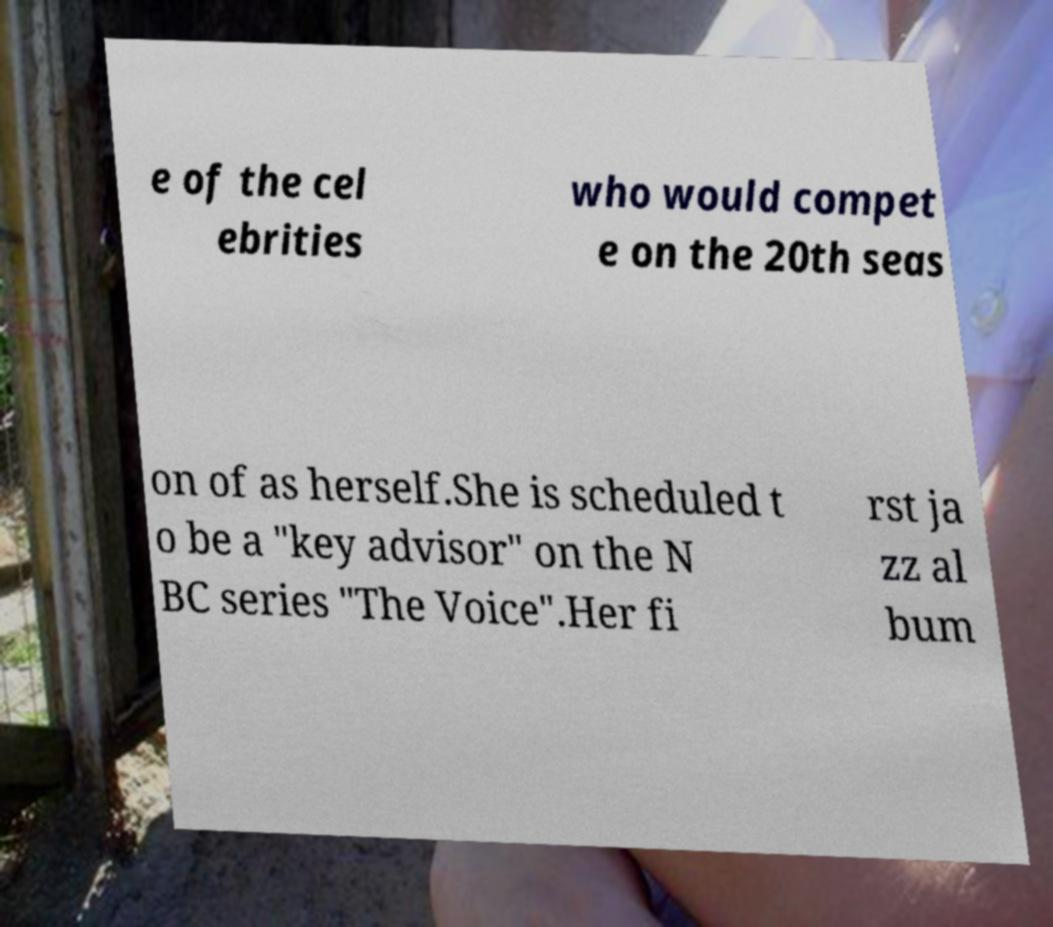Please read and relay the text visible in this image. What does it say? e of the cel ebrities who would compet e on the 20th seas on of as herself.She is scheduled t o be a "key advisor" on the N BC series "The Voice".Her fi rst ja zz al bum 